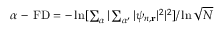Convert formula to latex. <formula><loc_0><loc_0><loc_500><loc_500>\begin{array} { r } { \alpha - F D = - \ln [ \sum _ { \alpha } | \sum _ { \alpha ^ { \prime } } | \psi _ { n , r } | ^ { 2 } | ^ { 2 } ] / \ln { \sqrt { N } } } \end{array}</formula> 